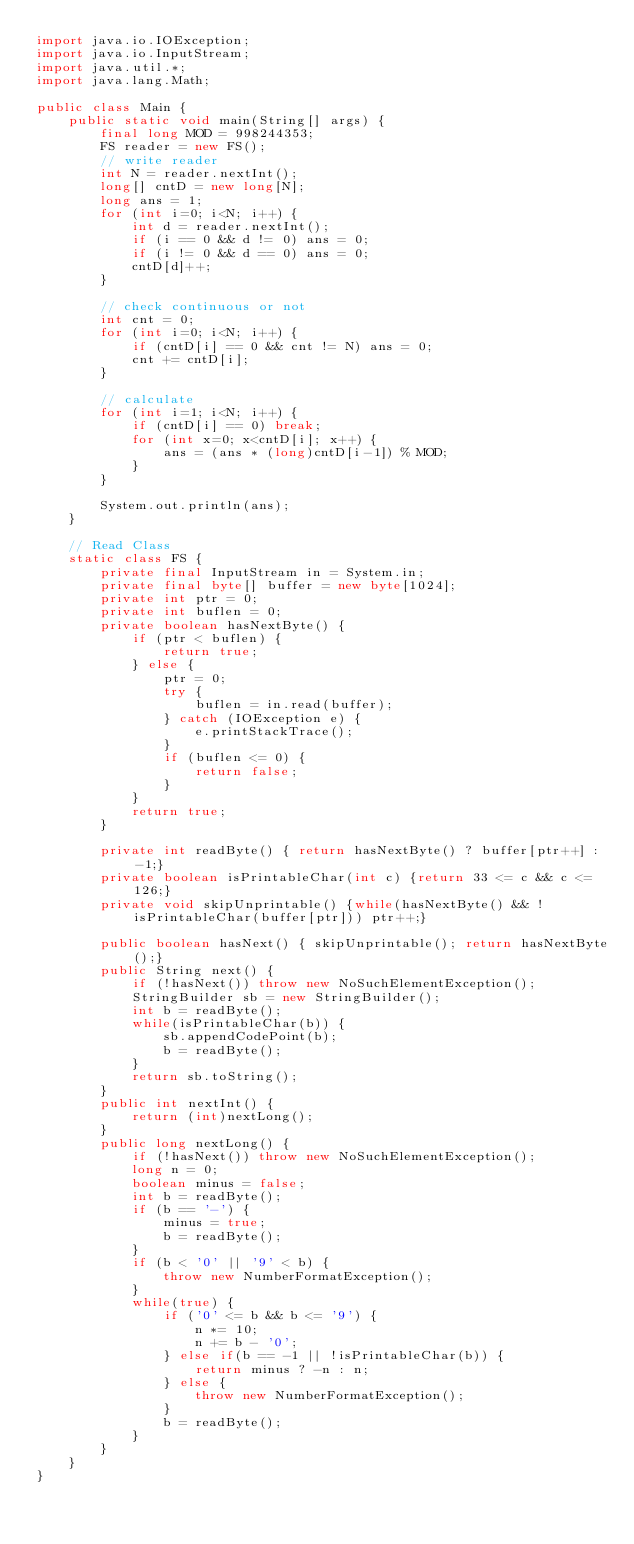Convert code to text. <code><loc_0><loc_0><loc_500><loc_500><_Java_>import java.io.IOException;
import java.io.InputStream;
import java.util.*;
import java.lang.Math;

public class Main {
    public static void main(String[] args) {
        final long MOD = 998244353;
        FS reader = new FS();
        // write reader
        int N = reader.nextInt();
        long[] cntD = new long[N];
        long ans = 1;
        for (int i=0; i<N; i++) {
            int d = reader.nextInt();
            if (i == 0 && d != 0) ans = 0;
            if (i != 0 && d == 0) ans = 0;
            cntD[d]++;
        }

        // check continuous or not
        int cnt = 0;
        for (int i=0; i<N; i++) {
            if (cntD[i] == 0 && cnt != N) ans = 0;
            cnt += cntD[i];
        }

        // calculate
        for (int i=1; i<N; i++) {
            if (cntD[i] == 0) break;
            for (int x=0; x<cntD[i]; x++) {
                ans = (ans * (long)cntD[i-1]) % MOD;
            }
        }

        System.out.println(ans);
    }

    // Read Class
    static class FS {
        private final InputStream in = System.in;
        private final byte[] buffer = new byte[1024];
        private int ptr = 0;
        private int buflen = 0;
        private boolean hasNextByte() {
            if (ptr < buflen) {
                return true;
            } else {
                ptr = 0;
                try {
                    buflen = in.read(buffer);
                } catch (IOException e) {
                    e.printStackTrace();
                }
                if (buflen <= 0) {
                    return false;
                }
            }
            return true;
        }
    
        private int readByte() { return hasNextByte() ? buffer[ptr++] : -1;}
        private boolean isPrintableChar(int c) {return 33 <= c && c <= 126;}
        private void skipUnprintable() {while(hasNextByte() && !isPrintableChar(buffer[ptr])) ptr++;}
    
        public boolean hasNext() { skipUnprintable(); return hasNextByte();}
        public String next() {
            if (!hasNext()) throw new NoSuchElementException();
            StringBuilder sb = new StringBuilder();
            int b = readByte();
            while(isPrintableChar(b)) {
                sb.appendCodePoint(b);
                b = readByte();
            }
            return sb.toString();
        }
        public int nextInt() {
            return (int)nextLong();
        }
        public long nextLong() {
            if (!hasNext()) throw new NoSuchElementException();
            long n = 0;
            boolean minus = false;
            int b = readByte();
            if (b == '-') {
                minus = true;
                b = readByte();
            }
            if (b < '0' || '9' < b) {
                throw new NumberFormatException();
            }
            while(true) {
                if ('0' <= b && b <= '9') {
                    n *= 10;
                    n += b - '0';
                } else if(b == -1 || !isPrintableChar(b)) {
                    return minus ? -n : n;
                } else {
                    throw new NumberFormatException();
                }
                b = readByte();
            }
        }
    }
}

</code> 